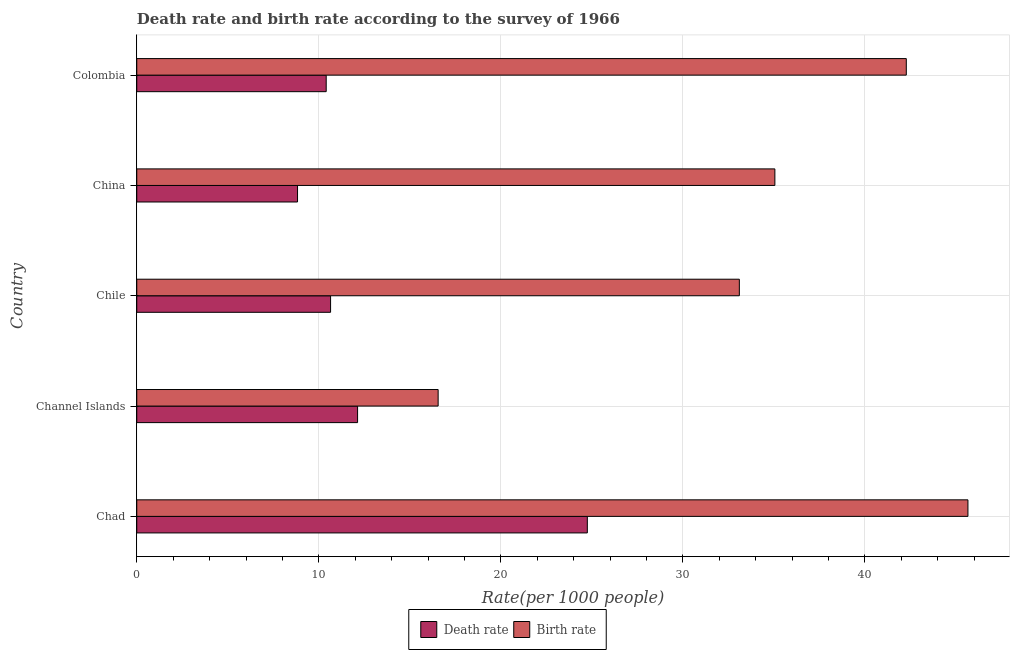How many different coloured bars are there?
Offer a very short reply. 2. How many groups of bars are there?
Your answer should be compact. 5. Are the number of bars per tick equal to the number of legend labels?
Provide a succinct answer. Yes. In how many cases, is the number of bars for a given country not equal to the number of legend labels?
Keep it short and to the point. 0. What is the death rate in Chile?
Provide a succinct answer. 10.65. Across all countries, what is the maximum death rate?
Offer a very short reply. 24.75. Across all countries, what is the minimum death rate?
Provide a short and direct response. 8.83. In which country was the death rate maximum?
Offer a terse response. Chad. What is the total death rate in the graph?
Make the answer very short. 66.76. What is the difference between the death rate in Chad and that in Chile?
Make the answer very short. 14.1. What is the difference between the birth rate in China and the death rate in Channel Islands?
Offer a very short reply. 22.92. What is the average birth rate per country?
Make the answer very short. 34.52. What is the difference between the birth rate and death rate in Chile?
Keep it short and to the point. 22.45. What is the ratio of the birth rate in Chile to that in Colombia?
Provide a succinct answer. 0.78. Is the death rate in Channel Islands less than that in China?
Your response must be concise. No. What is the difference between the highest and the second highest birth rate?
Make the answer very short. 3.39. What is the difference between the highest and the lowest death rate?
Give a very brief answer. 15.92. In how many countries, is the death rate greater than the average death rate taken over all countries?
Your answer should be very brief. 1. Is the sum of the death rate in Chad and China greater than the maximum birth rate across all countries?
Offer a very short reply. No. What does the 2nd bar from the top in Channel Islands represents?
Make the answer very short. Death rate. What does the 2nd bar from the bottom in Colombia represents?
Offer a terse response. Birth rate. How many bars are there?
Make the answer very short. 10. Are all the bars in the graph horizontal?
Your answer should be very brief. Yes. What is the difference between two consecutive major ticks on the X-axis?
Offer a very short reply. 10. Does the graph contain grids?
Your answer should be compact. Yes. Where does the legend appear in the graph?
Your response must be concise. Bottom center. How are the legend labels stacked?
Your answer should be very brief. Horizontal. What is the title of the graph?
Provide a succinct answer. Death rate and birth rate according to the survey of 1966. Does "Constant 2005 US$" appear as one of the legend labels in the graph?
Offer a very short reply. No. What is the label or title of the X-axis?
Give a very brief answer. Rate(per 1000 people). What is the label or title of the Y-axis?
Your answer should be compact. Country. What is the Rate(per 1000 people) in Death rate in Chad?
Provide a short and direct response. 24.75. What is the Rate(per 1000 people) in Birth rate in Chad?
Offer a terse response. 45.66. What is the Rate(per 1000 people) in Death rate in Channel Islands?
Offer a very short reply. 12.13. What is the Rate(per 1000 people) of Birth rate in Channel Islands?
Provide a succinct answer. 16.55. What is the Rate(per 1000 people) of Death rate in Chile?
Make the answer very short. 10.65. What is the Rate(per 1000 people) in Birth rate in Chile?
Give a very brief answer. 33.1. What is the Rate(per 1000 people) of Death rate in China?
Ensure brevity in your answer.  8.83. What is the Rate(per 1000 people) of Birth rate in China?
Give a very brief answer. 35.05. What is the Rate(per 1000 people) in Death rate in Colombia?
Ensure brevity in your answer.  10.4. What is the Rate(per 1000 people) in Birth rate in Colombia?
Your answer should be very brief. 42.27. Across all countries, what is the maximum Rate(per 1000 people) of Death rate?
Provide a short and direct response. 24.75. Across all countries, what is the maximum Rate(per 1000 people) of Birth rate?
Offer a terse response. 45.66. Across all countries, what is the minimum Rate(per 1000 people) of Death rate?
Provide a short and direct response. 8.83. Across all countries, what is the minimum Rate(per 1000 people) of Birth rate?
Offer a terse response. 16.55. What is the total Rate(per 1000 people) in Death rate in the graph?
Your answer should be very brief. 66.76. What is the total Rate(per 1000 people) of Birth rate in the graph?
Offer a terse response. 172.63. What is the difference between the Rate(per 1000 people) in Death rate in Chad and that in Channel Islands?
Your response must be concise. 12.62. What is the difference between the Rate(per 1000 people) in Birth rate in Chad and that in Channel Islands?
Offer a very short reply. 29.1. What is the difference between the Rate(per 1000 people) in Death rate in Chad and that in Chile?
Make the answer very short. 14.1. What is the difference between the Rate(per 1000 people) in Birth rate in Chad and that in Chile?
Your response must be concise. 12.56. What is the difference between the Rate(per 1000 people) of Death rate in Chad and that in China?
Make the answer very short. 15.92. What is the difference between the Rate(per 1000 people) of Birth rate in Chad and that in China?
Give a very brief answer. 10.61. What is the difference between the Rate(per 1000 people) of Death rate in Chad and that in Colombia?
Offer a very short reply. 14.34. What is the difference between the Rate(per 1000 people) in Birth rate in Chad and that in Colombia?
Your response must be concise. 3.39. What is the difference between the Rate(per 1000 people) of Death rate in Channel Islands and that in Chile?
Keep it short and to the point. 1.48. What is the difference between the Rate(per 1000 people) in Birth rate in Channel Islands and that in Chile?
Ensure brevity in your answer.  -16.55. What is the difference between the Rate(per 1000 people) in Death rate in Channel Islands and that in China?
Make the answer very short. 3.3. What is the difference between the Rate(per 1000 people) in Birth rate in Channel Islands and that in China?
Provide a succinct answer. -18.5. What is the difference between the Rate(per 1000 people) in Death rate in Channel Islands and that in Colombia?
Your answer should be very brief. 1.72. What is the difference between the Rate(per 1000 people) in Birth rate in Channel Islands and that in Colombia?
Offer a terse response. -25.71. What is the difference between the Rate(per 1000 people) of Death rate in Chile and that in China?
Make the answer very short. 1.82. What is the difference between the Rate(per 1000 people) in Birth rate in Chile and that in China?
Provide a short and direct response. -1.95. What is the difference between the Rate(per 1000 people) of Death rate in Chile and that in Colombia?
Provide a short and direct response. 0.24. What is the difference between the Rate(per 1000 people) in Birth rate in Chile and that in Colombia?
Ensure brevity in your answer.  -9.17. What is the difference between the Rate(per 1000 people) of Death rate in China and that in Colombia?
Keep it short and to the point. -1.57. What is the difference between the Rate(per 1000 people) of Birth rate in China and that in Colombia?
Provide a succinct answer. -7.22. What is the difference between the Rate(per 1000 people) of Death rate in Chad and the Rate(per 1000 people) of Birth rate in Channel Islands?
Your answer should be compact. 8.2. What is the difference between the Rate(per 1000 people) of Death rate in Chad and the Rate(per 1000 people) of Birth rate in Chile?
Provide a succinct answer. -8.35. What is the difference between the Rate(per 1000 people) of Death rate in Chad and the Rate(per 1000 people) of Birth rate in China?
Ensure brevity in your answer.  -10.3. What is the difference between the Rate(per 1000 people) in Death rate in Chad and the Rate(per 1000 people) in Birth rate in Colombia?
Your answer should be very brief. -17.52. What is the difference between the Rate(per 1000 people) in Death rate in Channel Islands and the Rate(per 1000 people) in Birth rate in Chile?
Provide a short and direct response. -20.97. What is the difference between the Rate(per 1000 people) in Death rate in Channel Islands and the Rate(per 1000 people) in Birth rate in China?
Offer a very short reply. -22.92. What is the difference between the Rate(per 1000 people) in Death rate in Channel Islands and the Rate(per 1000 people) in Birth rate in Colombia?
Provide a short and direct response. -30.14. What is the difference between the Rate(per 1000 people) in Death rate in Chile and the Rate(per 1000 people) in Birth rate in China?
Give a very brief answer. -24.4. What is the difference between the Rate(per 1000 people) of Death rate in Chile and the Rate(per 1000 people) of Birth rate in Colombia?
Provide a succinct answer. -31.62. What is the difference between the Rate(per 1000 people) of Death rate in China and the Rate(per 1000 people) of Birth rate in Colombia?
Your answer should be compact. -33.44. What is the average Rate(per 1000 people) of Death rate per country?
Your answer should be very brief. 13.35. What is the average Rate(per 1000 people) in Birth rate per country?
Offer a very short reply. 34.53. What is the difference between the Rate(per 1000 people) of Death rate and Rate(per 1000 people) of Birth rate in Chad?
Offer a terse response. -20.91. What is the difference between the Rate(per 1000 people) of Death rate and Rate(per 1000 people) of Birth rate in Channel Islands?
Offer a very short reply. -4.42. What is the difference between the Rate(per 1000 people) of Death rate and Rate(per 1000 people) of Birth rate in Chile?
Give a very brief answer. -22.45. What is the difference between the Rate(per 1000 people) of Death rate and Rate(per 1000 people) of Birth rate in China?
Your response must be concise. -26.22. What is the difference between the Rate(per 1000 people) in Death rate and Rate(per 1000 people) in Birth rate in Colombia?
Your answer should be compact. -31.86. What is the ratio of the Rate(per 1000 people) in Death rate in Chad to that in Channel Islands?
Ensure brevity in your answer.  2.04. What is the ratio of the Rate(per 1000 people) in Birth rate in Chad to that in Channel Islands?
Make the answer very short. 2.76. What is the ratio of the Rate(per 1000 people) of Death rate in Chad to that in Chile?
Keep it short and to the point. 2.32. What is the ratio of the Rate(per 1000 people) of Birth rate in Chad to that in Chile?
Ensure brevity in your answer.  1.38. What is the ratio of the Rate(per 1000 people) of Death rate in Chad to that in China?
Ensure brevity in your answer.  2.8. What is the ratio of the Rate(per 1000 people) in Birth rate in Chad to that in China?
Provide a short and direct response. 1.3. What is the ratio of the Rate(per 1000 people) of Death rate in Chad to that in Colombia?
Your response must be concise. 2.38. What is the ratio of the Rate(per 1000 people) in Birth rate in Chad to that in Colombia?
Offer a terse response. 1.08. What is the ratio of the Rate(per 1000 people) in Death rate in Channel Islands to that in Chile?
Your answer should be very brief. 1.14. What is the ratio of the Rate(per 1000 people) of Birth rate in Channel Islands to that in Chile?
Give a very brief answer. 0.5. What is the ratio of the Rate(per 1000 people) in Death rate in Channel Islands to that in China?
Offer a terse response. 1.37. What is the ratio of the Rate(per 1000 people) of Birth rate in Channel Islands to that in China?
Offer a very short reply. 0.47. What is the ratio of the Rate(per 1000 people) of Death rate in Channel Islands to that in Colombia?
Give a very brief answer. 1.17. What is the ratio of the Rate(per 1000 people) in Birth rate in Channel Islands to that in Colombia?
Give a very brief answer. 0.39. What is the ratio of the Rate(per 1000 people) in Death rate in Chile to that in China?
Your answer should be very brief. 1.21. What is the ratio of the Rate(per 1000 people) of Birth rate in Chile to that in China?
Give a very brief answer. 0.94. What is the ratio of the Rate(per 1000 people) in Death rate in Chile to that in Colombia?
Keep it short and to the point. 1.02. What is the ratio of the Rate(per 1000 people) of Birth rate in Chile to that in Colombia?
Your response must be concise. 0.78. What is the ratio of the Rate(per 1000 people) in Death rate in China to that in Colombia?
Offer a very short reply. 0.85. What is the ratio of the Rate(per 1000 people) of Birth rate in China to that in Colombia?
Provide a succinct answer. 0.83. What is the difference between the highest and the second highest Rate(per 1000 people) in Death rate?
Make the answer very short. 12.62. What is the difference between the highest and the second highest Rate(per 1000 people) in Birth rate?
Provide a succinct answer. 3.39. What is the difference between the highest and the lowest Rate(per 1000 people) of Death rate?
Make the answer very short. 15.92. What is the difference between the highest and the lowest Rate(per 1000 people) of Birth rate?
Give a very brief answer. 29.1. 